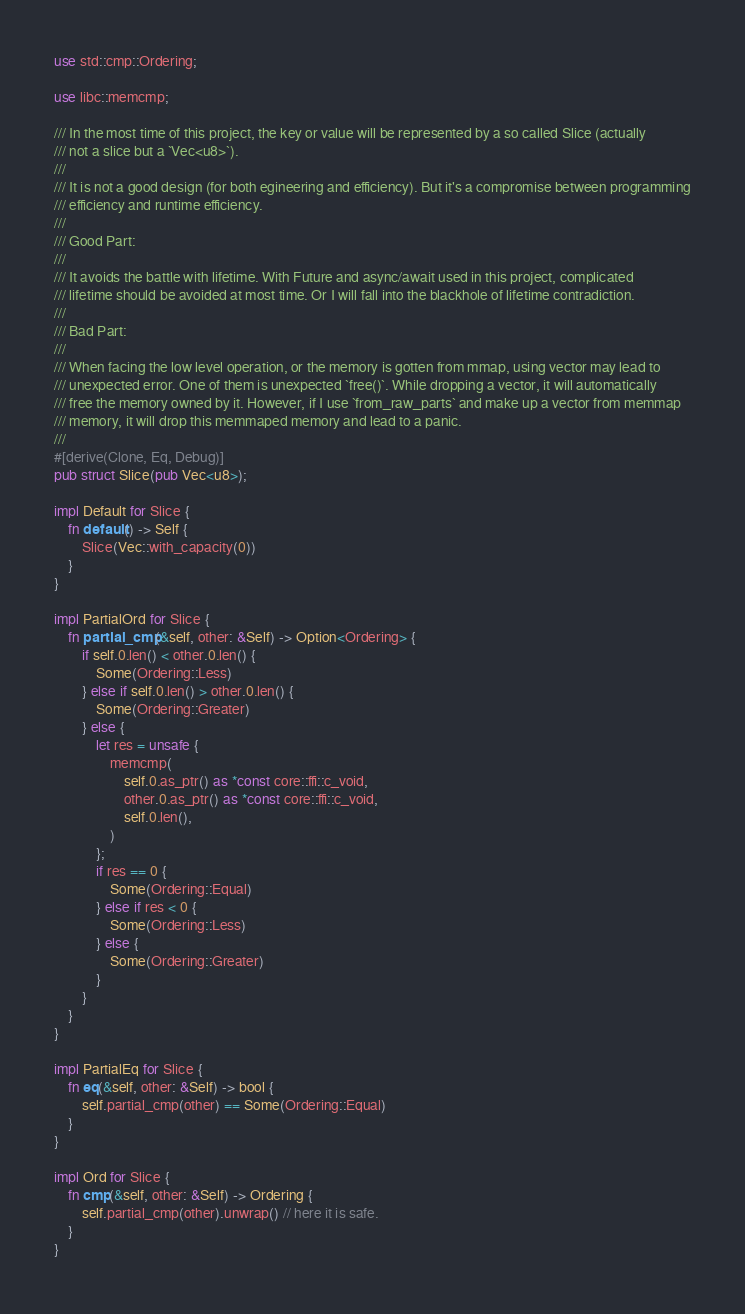Convert code to text. <code><loc_0><loc_0><loc_500><loc_500><_Rust_>use std::cmp::Ordering;

use libc::memcmp;

/// In the most time of this project, the key or value will be represented by a so called Slice (actually
/// not a slice but a `Vec<u8>`).
///
/// It is not a good design (for both egineering and efficiency). But it's a compromise between programming
/// efficiency and runtime efficiency.
///
/// Good Part:
///
/// It avoids the battle with lifetime. With Future and async/await used in this project, complicated
/// lifetime should be avoided at most time. Or I will fall into the blackhole of lifetime contradiction.
///
/// Bad Part:
///
/// When facing the low level operation, or the memory is gotten from mmap, using vector may lead to
/// unexpected error. One of them is unexpected `free()`. While dropping a vector, it will automatically
/// free the memory owned by it. However, if I use `from_raw_parts` and make up a vector from memmap
/// memory, it will drop this memmaped memory and lead to a panic.
///
#[derive(Clone, Eq, Debug)]
pub struct Slice(pub Vec<u8>);

impl Default for Slice {
    fn default() -> Self {
        Slice(Vec::with_capacity(0))
    }
}

impl PartialOrd for Slice {
    fn partial_cmp(&self, other: &Self) -> Option<Ordering> {
        if self.0.len() < other.0.len() {
            Some(Ordering::Less)
        } else if self.0.len() > other.0.len() {
            Some(Ordering::Greater)
        } else {
            let res = unsafe {
                memcmp(
                    self.0.as_ptr() as *const core::ffi::c_void,
                    other.0.as_ptr() as *const core::ffi::c_void,
                    self.0.len(),
                )
            };
            if res == 0 {
                Some(Ordering::Equal)
            } else if res < 0 {
                Some(Ordering::Less)
            } else {
                Some(Ordering::Greater)
            }
        }
    }
}

impl PartialEq for Slice {
    fn eq(&self, other: &Self) -> bool {
        self.partial_cmp(other) == Some(Ordering::Equal)
    }
}

impl Ord for Slice {
    fn cmp(&self, other: &Self) -> Ordering {
        self.partial_cmp(other).unwrap() // here it is safe.
    }
}
</code> 